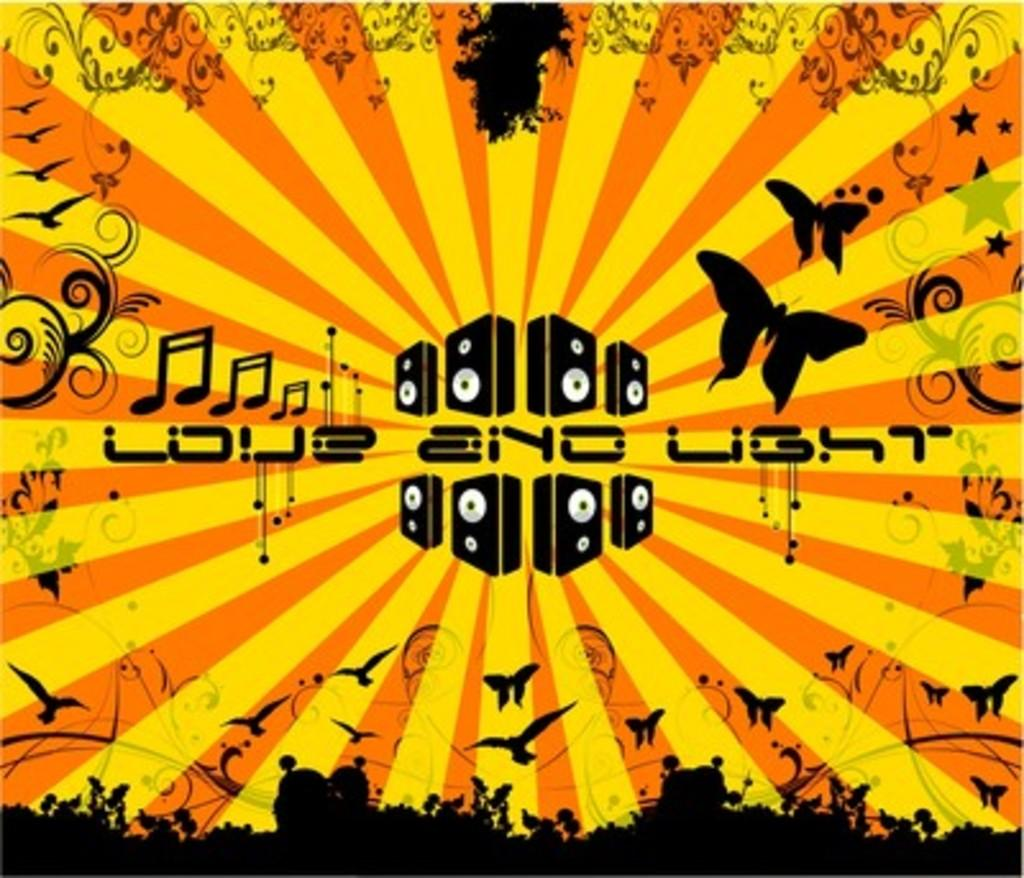<image>
Summarize the visual content of the image. A yellow and orange poster with love and light written across it. 